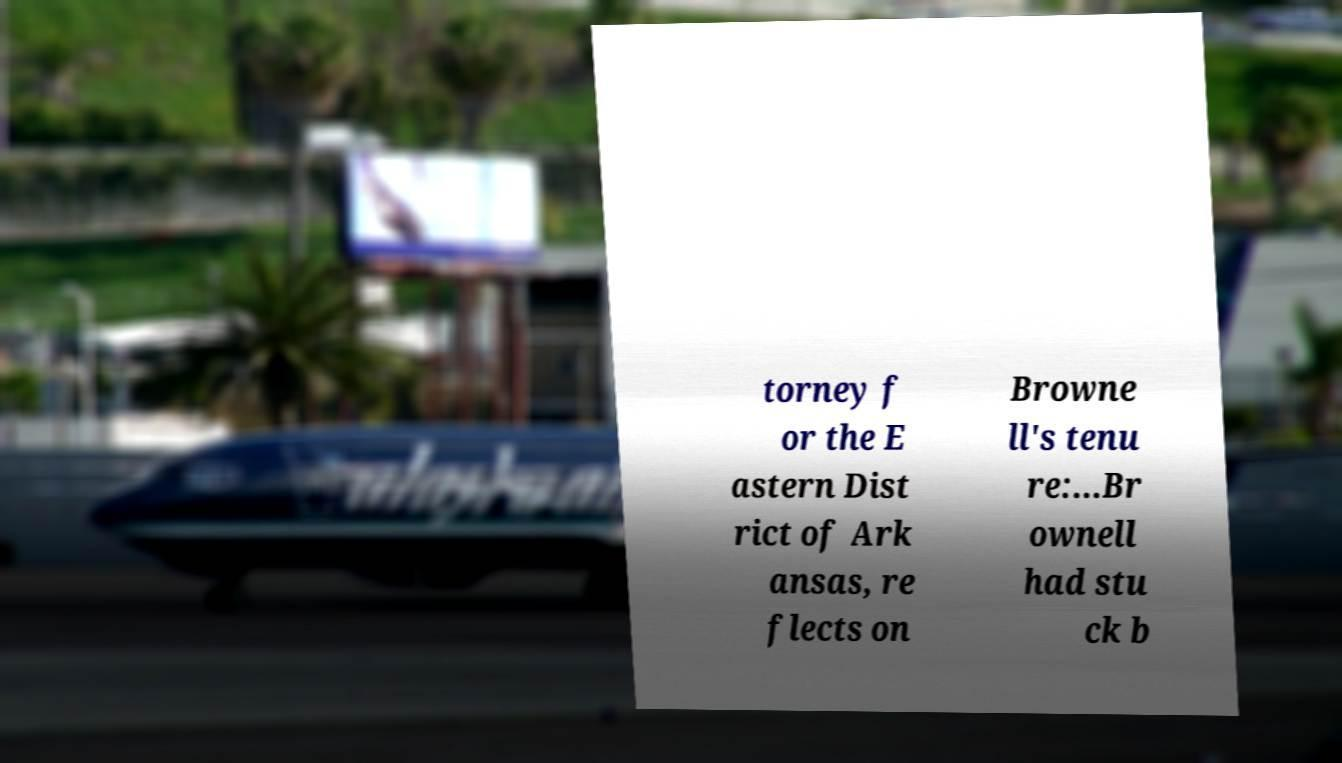For documentation purposes, I need the text within this image transcribed. Could you provide that? torney f or the E astern Dist rict of Ark ansas, re flects on Browne ll's tenu re:...Br ownell had stu ck b 